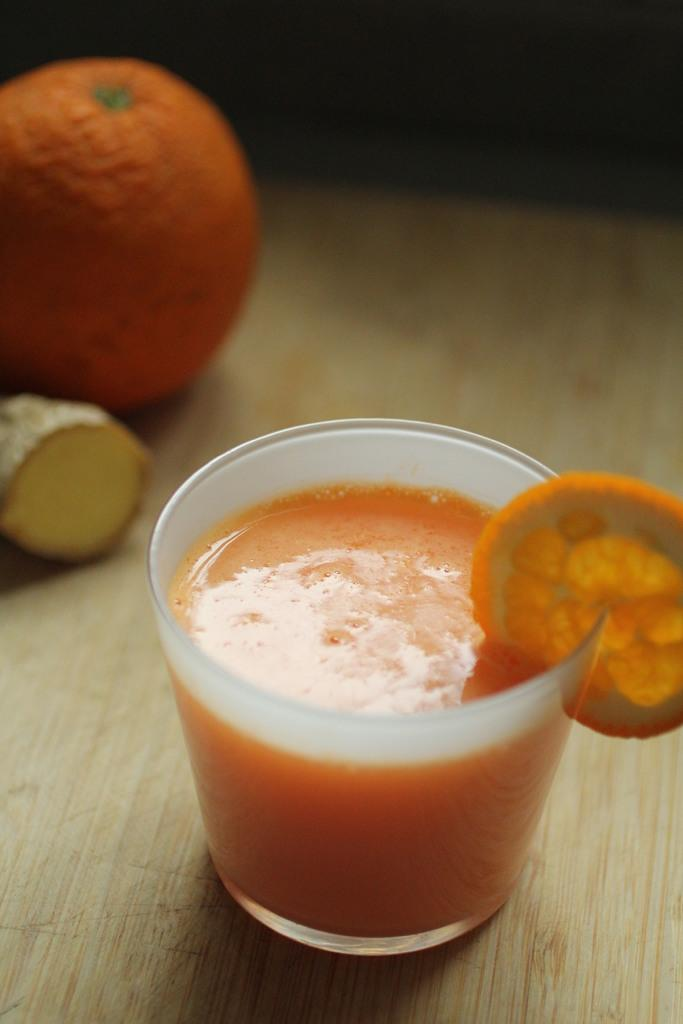What is in the glass that is visible in the image? There is juice in a glass in the image. Where is the glass placed in the image? The glass is on a wooden surface. What can be seen in the left top of the image? There is an orange and a circular shape thing in the left top of the image. What type of teeth can be seen in the image? There are no teeth present in the image. Is the queen visible in the image? There is no queen present in the image. 